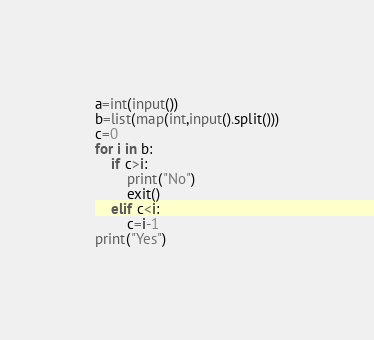Convert code to text. <code><loc_0><loc_0><loc_500><loc_500><_Python_>a=int(input())
b=list(map(int,input().split()))
c=0
for i in b:
    if c>i:
        print("No")
        exit()
    elif c<i:
        c=i-1
print("Yes")
</code> 